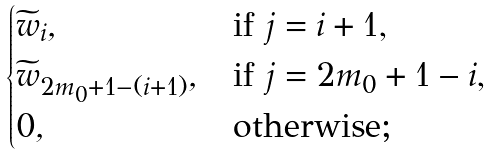Convert formula to latex. <formula><loc_0><loc_0><loc_500><loc_500>\begin{cases} { \widetilde { w } } _ { i } , & \text {if $j=i+1$,} \\ { \widetilde { w } } _ { 2 m _ { 0 } + 1 - ( i + 1 ) } , & \text {if $j=2m_{0}+1-i$,} \\ 0 , & \text {otherwise;} \end{cases}</formula> 